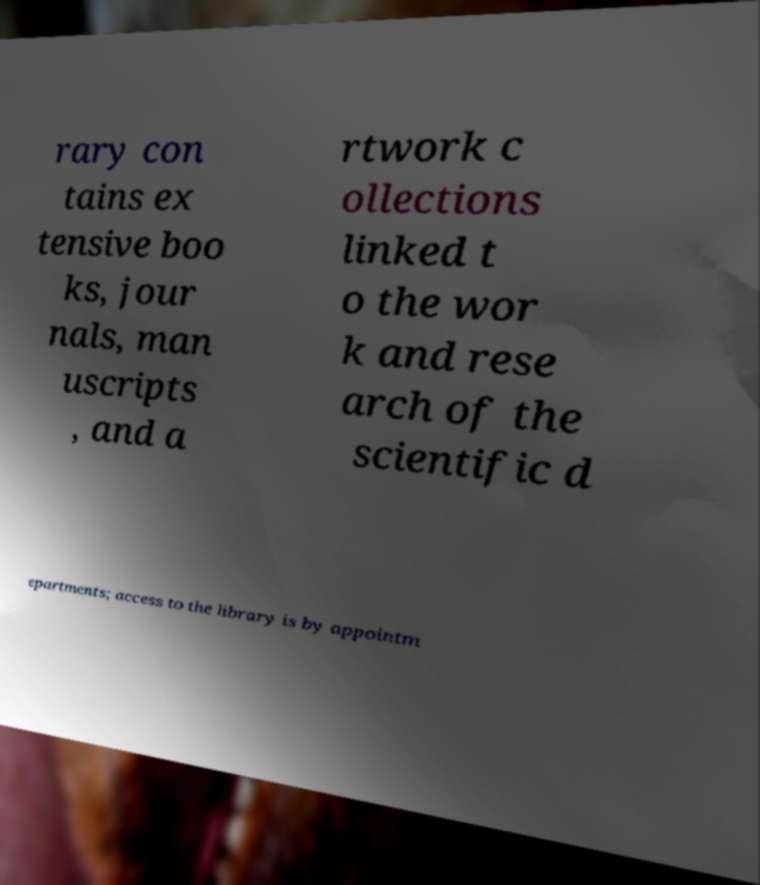Can you accurately transcribe the text from the provided image for me? rary con tains ex tensive boo ks, jour nals, man uscripts , and a rtwork c ollections linked t o the wor k and rese arch of the scientific d epartments; access to the library is by appointm 